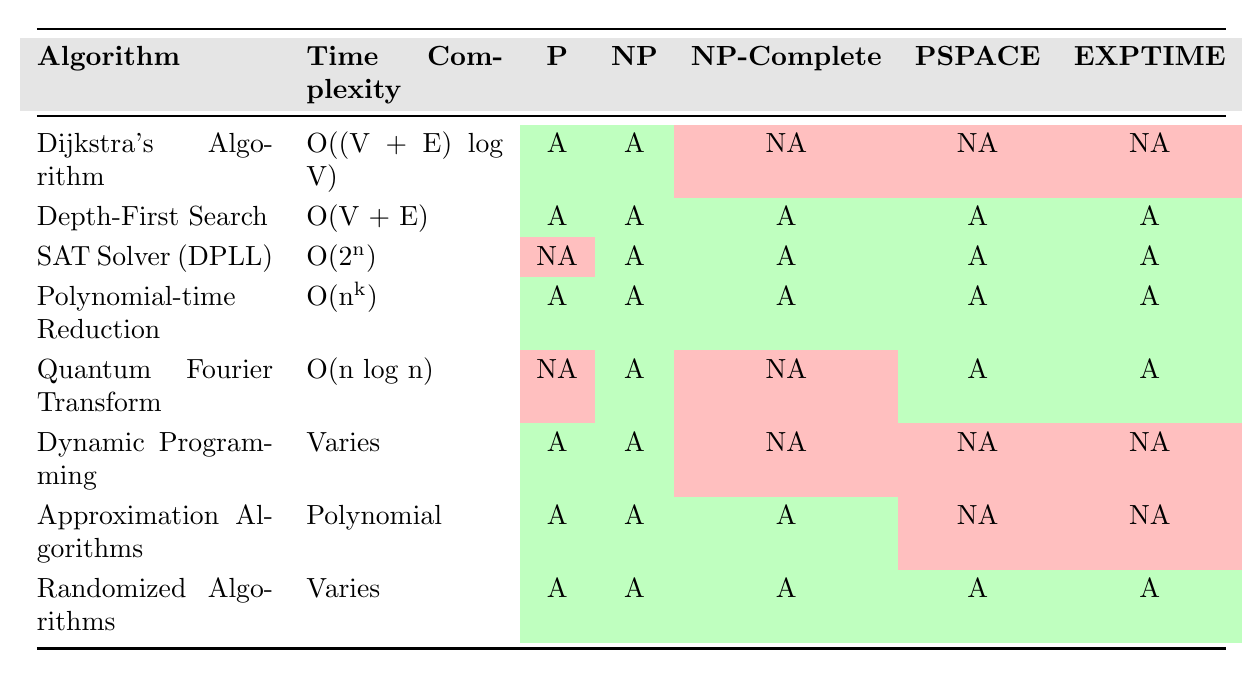What is the time complexity of Dijkstra's Algorithm? By referring to the row corresponding to Dijkstra's Algorithm, the time complexity is given as O((V + E) log V).
Answer: O((V + E) log V) Which algorithms are applicable to NP-Complete problems? Looking at the rows where NP-Complete is marked as "Applicable," the algorithms are Depth-First Search, SAT Solver (DPLL), Polynomial-time Reduction, and Approximation Algorithms.
Answer: Depth-First Search, SAT Solver (DPLL), Polynomial-time Reduction, Approximation Algorithms Is the Quantum Fourier Transform applicable to P? Checking the row for Quantum Fourier Transform, the P column is marked as "Not Applicable." Thus, it is not applicable to P.
Answer: No How many algorithms have a time complexity that varies? The algorithms with a varying time complexity are Depth-First Search, Dynamic Programming, and Randomized Algorithms. Counting these entries gives a total of three.
Answer: 3 Is Depth-First Search applicable to EXPTIME? Looking at the Depth-First Search row, the EXPTIME column is marked as "Applicable." Thus, it is applicable to EXPTIME.
Answer: Yes What is the time complexity of SAT Solver (DPLL) and which classes is it applicable to? The time complexity of SAT Solver (DPLL) is O(2^n). It is applicable to NP, NP-Complete, PSPACE, and EXPTIME, but not to P.
Answer: O(2^n); NP, NP-Complete, PSPACE, EXPTIME Can you list the algorithms that are applicable to both P and NP? By reviewing the table for rows applicable to both P and NP simultaneously, the following algorithms qualify: Dijkstra's Algorithm, Depth-First Search, Polynomial-time Reduction, Dynamic Programming, Approximation Algorithms, and Randomized Algorithms.
Answer: Dijkstra's Algorithm, Depth-First Search, Polynomial-time Reduction, Dynamic Programming, Approximation Algorithms, Randomized Algorithms Which algorithm has linear time complexity? Analyzing the time complexities, Depth-First Search has a time complexity of O(V + E), which can be considered linear in terms of the number of vertices and edges.
Answer: Depth-First Search Among the algorithms listed, which one is not applicable to both P and EXPTIME? Checking the rows for applicability to both P and EXPTIME, the Dynamic Programming algorithm is marked as "Not Applicable" to EXPTIME.
Answer: Dynamic Programming What is the difference in applicability between Polynomial-time Reduction and SAT Solver (DPLL) in terms of P? Polynomial-time Reduction is applicable to P, as indicated by its "Applicable" status in the P column, while SAT Solver (DPLL) is marked as "Not Applicable." Thus, the difference is that only Polynomial-time Reduction applies to P.
Answer: Polynomial-time Reduction applies; SAT Solver (DPLL) does not 